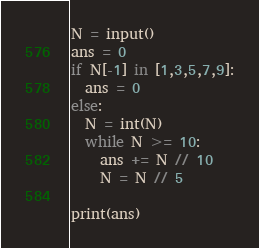<code> <loc_0><loc_0><loc_500><loc_500><_Python_>N = input()
ans = 0
if N[-1] in [1,3,5,7,9]:
  ans = 0
else:
  N = int(N)
  while N >= 10:
    ans += N // 10
    N = N // 5

print(ans)</code> 